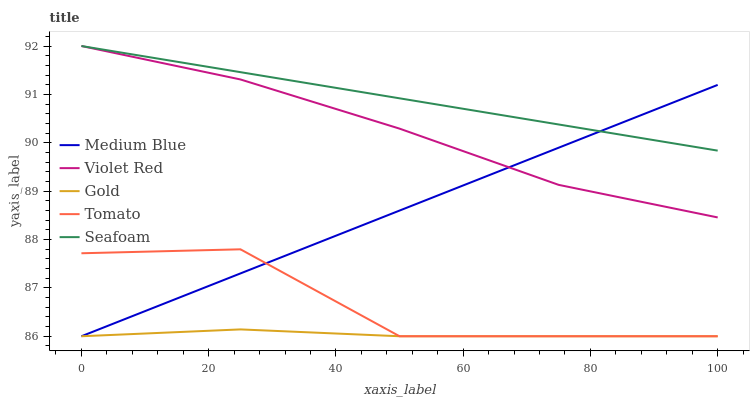Does Gold have the minimum area under the curve?
Answer yes or no. Yes. Does Seafoam have the maximum area under the curve?
Answer yes or no. Yes. Does Violet Red have the minimum area under the curve?
Answer yes or no. No. Does Violet Red have the maximum area under the curve?
Answer yes or no. No. Is Medium Blue the smoothest?
Answer yes or no. Yes. Is Tomato the roughest?
Answer yes or no. Yes. Is Violet Red the smoothest?
Answer yes or no. No. Is Violet Red the roughest?
Answer yes or no. No. Does Violet Red have the lowest value?
Answer yes or no. No. Does Seafoam have the highest value?
Answer yes or no. Yes. Does Medium Blue have the highest value?
Answer yes or no. No. Is Tomato less than Seafoam?
Answer yes or no. Yes. Is Violet Red greater than Tomato?
Answer yes or no. Yes. Does Seafoam intersect Violet Red?
Answer yes or no. Yes. Is Seafoam less than Violet Red?
Answer yes or no. No. Is Seafoam greater than Violet Red?
Answer yes or no. No. Does Tomato intersect Seafoam?
Answer yes or no. No. 